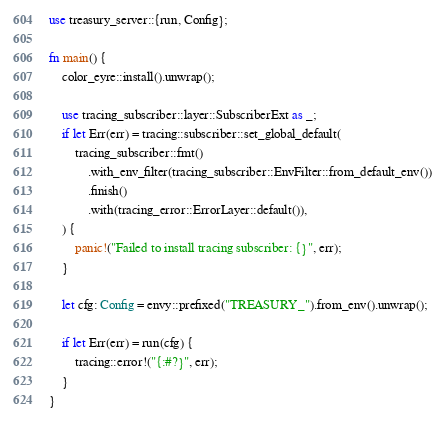Convert code to text. <code><loc_0><loc_0><loc_500><loc_500><_Rust_>use treasury_server::{run, Config};

fn main() {
    color_eyre::install().unwrap();

    use tracing_subscriber::layer::SubscriberExt as _;
    if let Err(err) = tracing::subscriber::set_global_default(
        tracing_subscriber::fmt()
            .with_env_filter(tracing_subscriber::EnvFilter::from_default_env())
            .finish()
            .with(tracing_error::ErrorLayer::default()),
    ) {
        panic!("Failed to install tracing subscriber: {}", err);
    }

    let cfg: Config = envy::prefixed("TREASURY_").from_env().unwrap();

    if let Err(err) = run(cfg) {
        tracing::error!("{:#?}", err);
    }
}
</code> 